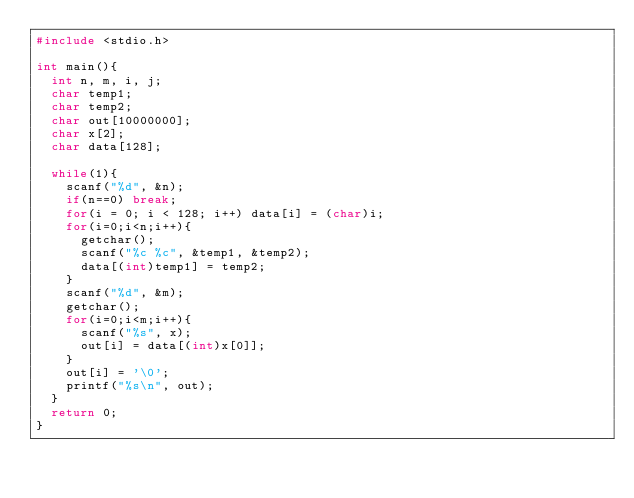Convert code to text. <code><loc_0><loc_0><loc_500><loc_500><_C_>#include <stdio.h>

int main(){
  int n, m, i, j;
  char temp1;
  char temp2;
  char out[10000000];
  char x[2];
  char data[128];

  while(1){
    scanf("%d", &n);
    if(n==0) break;
    for(i = 0; i < 128; i++) data[i] = (char)i;
    for(i=0;i<n;i++){
      getchar();
      scanf("%c %c", &temp1, &temp2);
      data[(int)temp1] = temp2;
    }
    scanf("%d", &m);
    getchar();
    for(i=0;i<m;i++){
      scanf("%s", x);
      out[i] = data[(int)x[0]];
    }
    out[i] = '\0';
    printf("%s\n", out);
  }
  return 0;
}</code> 